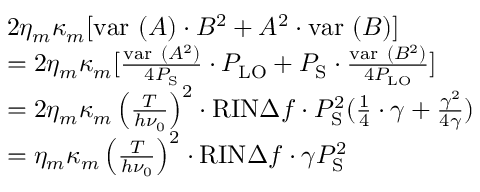<formula> <loc_0><loc_0><loc_500><loc_500>\begin{array} { r l & { 2 \eta _ { m } \kappa _ { m } [ v a r ( A ) \cdot B ^ { 2 } + A ^ { 2 } \cdot v a r ( B ) ] } \\ & { = 2 \eta _ { m } \kappa _ { m } [ \frac { v a r ( A ^ { 2 } ) } { 4 P _ { S } } \cdot P _ { L O } + P _ { S } \cdot \frac { v a r ( B ^ { 2 } ) } { 4 P _ { L O } } ] } \\ & { = 2 \eta _ { m } \kappa _ { m } \left ( \frac { T } { h \nu _ { 0 } } \right ) ^ { 2 } \cdot R I N \Delta f \cdot P _ { S } ^ { 2 } ( \frac { 1 } { 4 } \cdot \gamma + \frac { \gamma ^ { 2 } } { 4 \gamma } ) } \\ & { = \eta _ { m } \kappa _ { m } \left ( \frac { T } { h \nu _ { 0 } } \right ) ^ { 2 } \cdot R I N \Delta f \cdot \gamma P _ { S } ^ { 2 } } \end{array}</formula> 